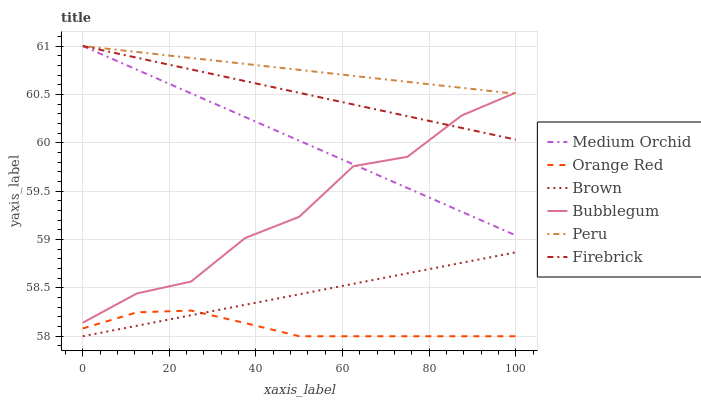Does Orange Red have the minimum area under the curve?
Answer yes or no. Yes. Does Peru have the maximum area under the curve?
Answer yes or no. Yes. Does Firebrick have the minimum area under the curve?
Answer yes or no. No. Does Firebrick have the maximum area under the curve?
Answer yes or no. No. Is Medium Orchid the smoothest?
Answer yes or no. Yes. Is Bubblegum the roughest?
Answer yes or no. Yes. Is Firebrick the smoothest?
Answer yes or no. No. Is Firebrick the roughest?
Answer yes or no. No. Does Firebrick have the lowest value?
Answer yes or no. No. Does Bubblegum have the highest value?
Answer yes or no. No. Is Brown less than Medium Orchid?
Answer yes or no. Yes. Is Bubblegum greater than Brown?
Answer yes or no. Yes. Does Brown intersect Medium Orchid?
Answer yes or no. No. 